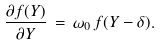<formula> <loc_0><loc_0><loc_500><loc_500>\frac { \partial f ( Y ) } { \partial Y } \, = \, \omega _ { 0 } \, f ( Y - \delta ) .</formula> 